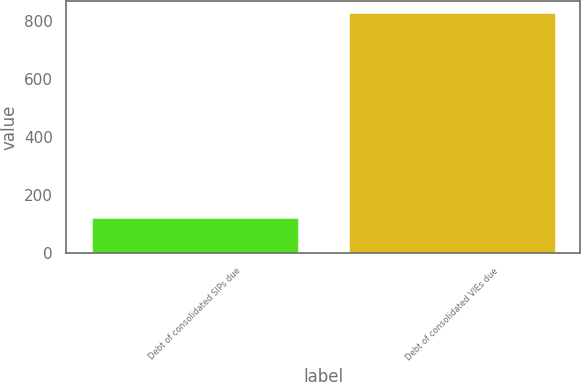<chart> <loc_0><loc_0><loc_500><loc_500><bar_chart><fcel>Debt of consolidated SIPs due<fcel>Debt of consolidated VIEs due<nl><fcel>122.3<fcel>828.5<nl></chart> 